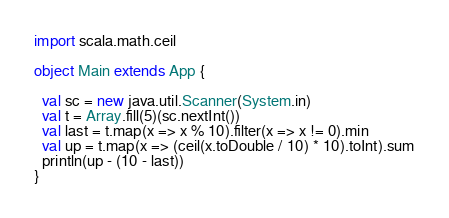<code> <loc_0><loc_0><loc_500><loc_500><_Scala_>import scala.math.ceil

object Main extends App {

  val sc = new java.util.Scanner(System.in) 
  val t = Array.fill(5)(sc.nextInt())
  val last = t.map(x => x % 10).filter(x => x != 0).min
  val up = t.map(x => (ceil(x.toDouble / 10) * 10).toInt).sum
  println(up - (10 - last))
}</code> 